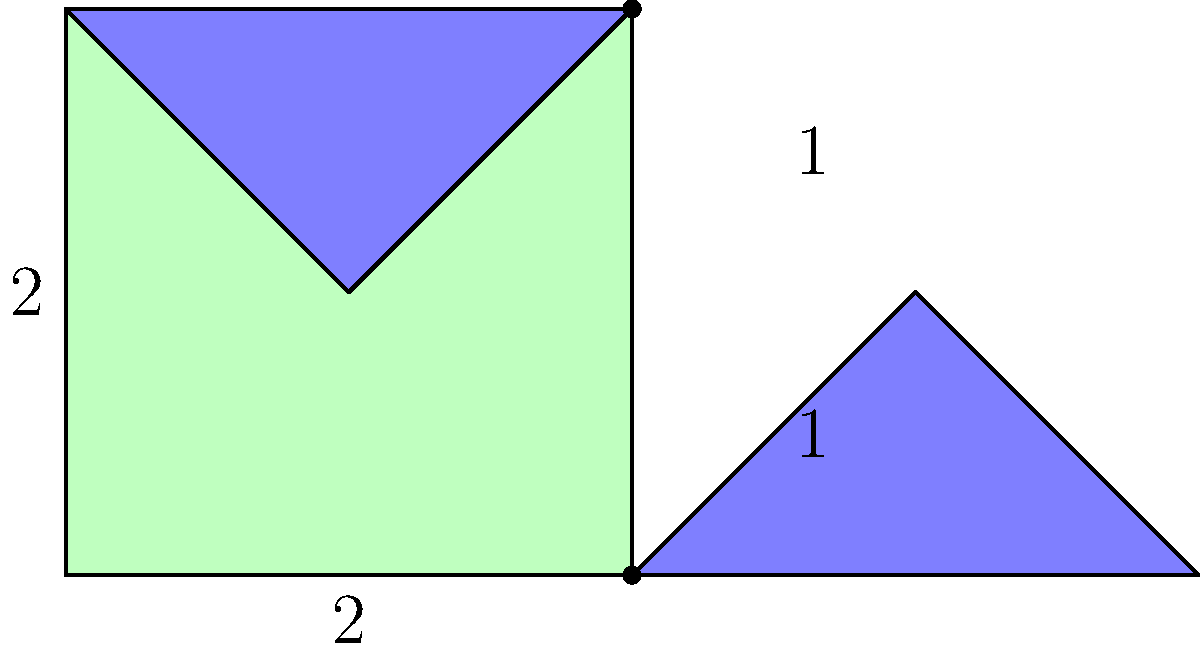A traditional quilt maker is crafting a square quilt with additional triangular pieces. The main square piece measures 2 feet on each side. Two right-angled triangular pieces are attached to the right side of the square, each with a base of 1 foot and a height of 1 foot. What is the total area of the quilt in square feet? To find the total area of the quilt, we need to calculate the areas of the square and triangular pieces separately, then add them together.

Step 1: Calculate the area of the square piece
- The square has sides of 2 feet
- Area of a square = side length × side length
- Area of square = $2 \times 2 = 4$ square feet

Step 2: Calculate the area of one triangular piece
- The triangle has a base of 1 foot and a height of 1 foot
- Area of a triangle = $\frac{1}{2} \times$ base $\times$ height
- Area of one triangle = $\frac{1}{2} \times 1 \times 1 = 0.5$ square feet

Step 3: Calculate the total area of both triangular pieces
- There are two identical triangular pieces
- Total area of triangles = $2 \times 0.5 = 1$ square foot

Step 4: Sum up the areas to get the total quilt area
- Total area = Area of square + Area of triangles
- Total area = $4 + 1 = 5$ square feet

Therefore, the total area of the quilt is 5 square feet.
Answer: $5$ square feet 